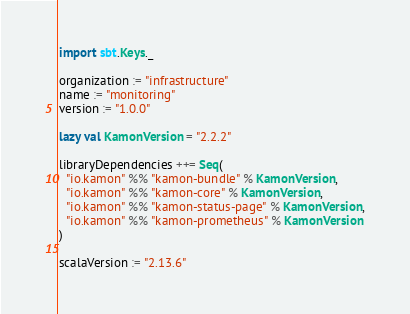Convert code to text. <code><loc_0><loc_0><loc_500><loc_500><_Scala_>import sbt.Keys._

organization := "infrastructure"
name := "monitoring"
version := "1.0.0"

lazy val KamonVersion = "2.2.2"

libraryDependencies ++= Seq(
  "io.kamon" %% "kamon-bundle" % KamonVersion,
  "io.kamon" %% "kamon-core" % KamonVersion,
  "io.kamon" %% "kamon-status-page" % KamonVersion,
  "io.kamon" %% "kamon-prometheus" % KamonVersion
)

scalaVersion := "2.13.6"
</code> 